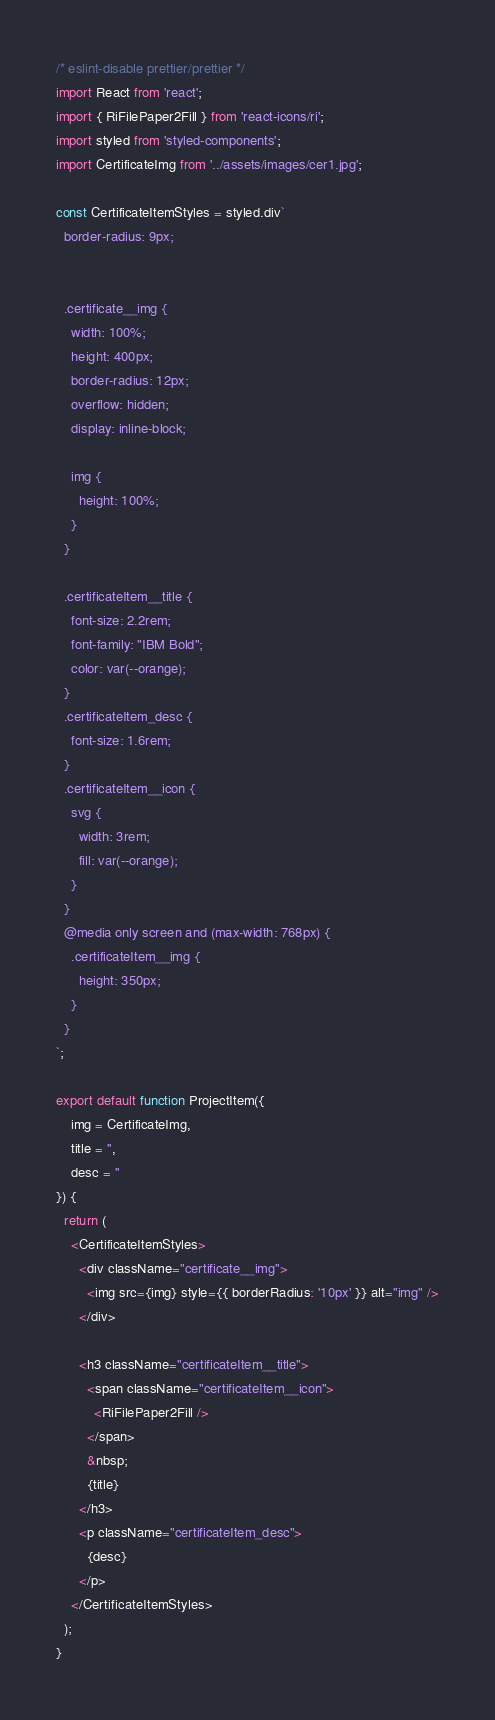Convert code to text. <code><loc_0><loc_0><loc_500><loc_500><_JavaScript_>/* eslint-disable prettier/prettier */
import React from 'react';
import { RiFilePaper2Fill } from 'react-icons/ri';
import styled from 'styled-components';
import CertificateImg from '../assets/images/cer1.jpg';

const CertificateItemStyles = styled.div`
  border-radius: 9px;
 

  .certificate__img {
    width: 100%;
    height: 400px;
    border-radius: 12px;
    overflow: hidden;
    display: inline-block;
    
    img {
      height: 100%;
    }
  }

  .certificateItem__title {
    font-size: 2.2rem;
    font-family: "IBM Bold";
    color: var(--orange);
  }
  .certificateItem_desc {
    font-size: 1.6rem;
  }
  .certificateItem__icon {
    svg {
      width: 3rem;
      fill: var(--orange);
    }
  }
  @media only screen and (max-width: 768px) {
    .certificateItem__img {
      height: 350px;
    }
  }
`;

export default function ProjectItem({ 
    img = CertificateImg,
    title = '',
    desc = '' 
}) {
  return (
    <CertificateItemStyles>
      <div className="certificate__img">
        <img src={img} style={{ borderRadius: '10px' }} alt="img" />
      </div>

      <h3 className="certificateItem__title">
        <span className="certificateItem__icon">
          <RiFilePaper2Fill />
        </span>
        &nbsp;
        {title}
      </h3>
      <p className="certificateItem_desc">
        {desc}
      </p>
    </CertificateItemStyles>
  );
}
</code> 